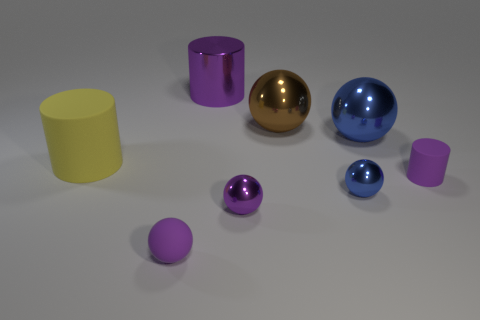Subtract 1 balls. How many balls are left? 4 Subtract all large blue metal balls. How many balls are left? 4 Subtract all yellow spheres. Subtract all brown cylinders. How many spheres are left? 5 Add 2 tiny spheres. How many objects exist? 10 Subtract all cylinders. How many objects are left? 5 Add 7 blue metal objects. How many blue metal objects exist? 9 Subtract 0 cyan cylinders. How many objects are left? 8 Subtract all large purple rubber objects. Subtract all small metal spheres. How many objects are left? 6 Add 5 shiny balls. How many shiny balls are left? 9 